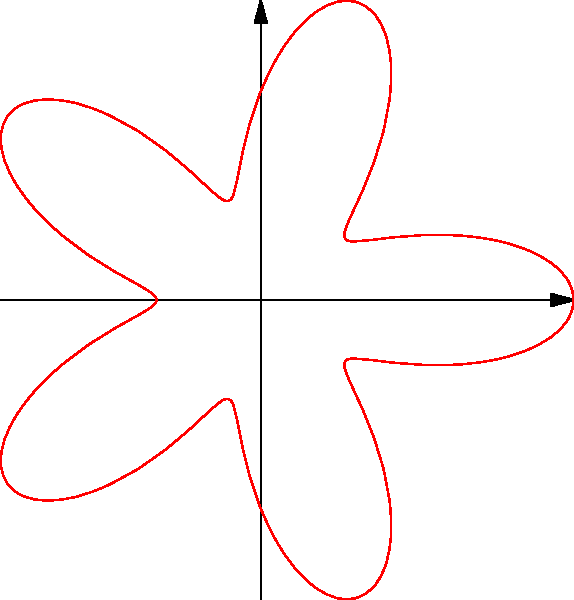In both classical and street art, star-shaped patterns are common motifs. The polar equation $r = 2 + \cos(5\theta)$ creates a star-like shape. How many points does this star have? To determine the number of points in the star shape, we need to analyze the polar equation $r = 2 + \cos(5\theta)$:

1. The cosine function has a period of $2\pi$.

2. In this equation, the argument of cosine is $5\theta$. This means the function will complete 5 full cycles as $\theta$ goes from 0 to $2\pi$.

3. Each cycle of the cosine function corresponds to one "point" of the star, where the radius reaches its maximum value.

4. The number of cycles (and thus points) is determined by the coefficient of $\theta$ in the cosine function.

5. In this case, the coefficient is 5, so the star will have 5 points.

6. We can verify this by looking at the graph, which clearly shows a 5-pointed star shape.

This star pattern combines mathematical precision (appealing to classical art) with a bold, symmetrical design (reminiscent of street art motifs), bridging the gap between these two art forms.
Answer: 5 points 